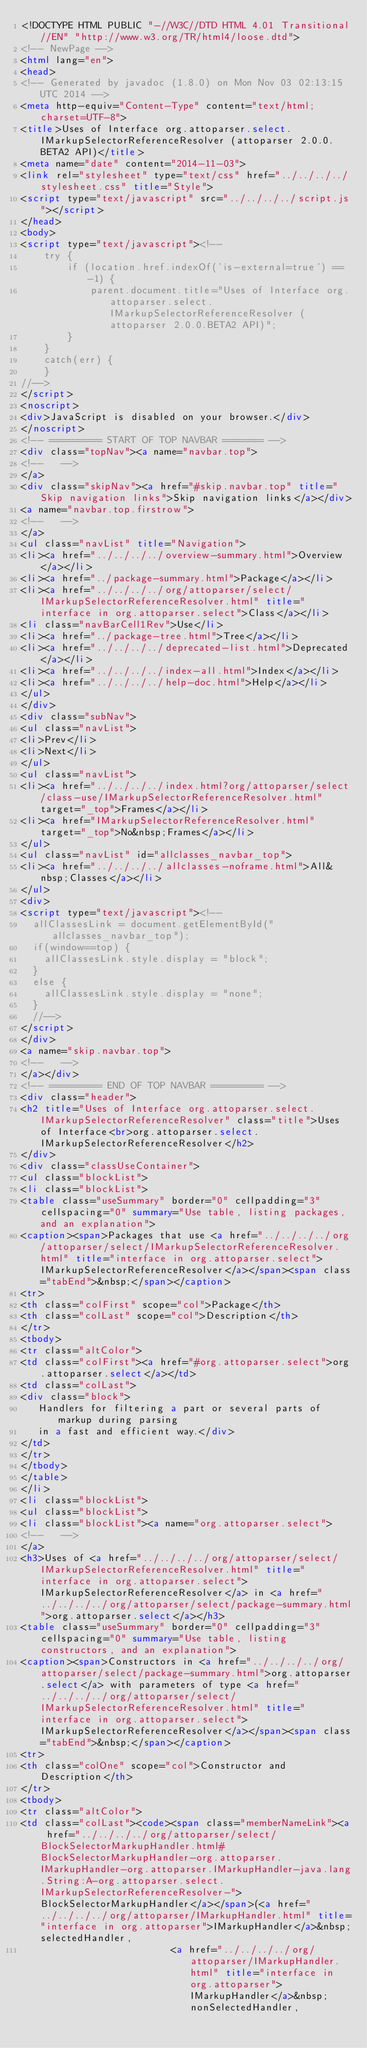<code> <loc_0><loc_0><loc_500><loc_500><_HTML_><!DOCTYPE HTML PUBLIC "-//W3C//DTD HTML 4.01 Transitional//EN" "http://www.w3.org/TR/html4/loose.dtd">
<!-- NewPage -->
<html lang="en">
<head>
<!-- Generated by javadoc (1.8.0) on Mon Nov 03 02:13:15 UTC 2014 -->
<meta http-equiv="Content-Type" content="text/html; charset=UTF-8">
<title>Uses of Interface org.attoparser.select.IMarkupSelectorReferenceResolver (attoparser 2.0.0.BETA2 API)</title>
<meta name="date" content="2014-11-03">
<link rel="stylesheet" type="text/css" href="../../../../stylesheet.css" title="Style">
<script type="text/javascript" src="../../../../script.js"></script>
</head>
<body>
<script type="text/javascript"><!--
    try {
        if (location.href.indexOf('is-external=true') == -1) {
            parent.document.title="Uses of Interface org.attoparser.select.IMarkupSelectorReferenceResolver (attoparser 2.0.0.BETA2 API)";
        }
    }
    catch(err) {
    }
//-->
</script>
<noscript>
<div>JavaScript is disabled on your browser.</div>
</noscript>
<!-- ========= START OF TOP NAVBAR ======= -->
<div class="topNav"><a name="navbar.top">
<!--   -->
</a>
<div class="skipNav"><a href="#skip.navbar.top" title="Skip navigation links">Skip navigation links</a></div>
<a name="navbar.top.firstrow">
<!--   -->
</a>
<ul class="navList" title="Navigation">
<li><a href="../../../../overview-summary.html">Overview</a></li>
<li><a href="../package-summary.html">Package</a></li>
<li><a href="../../../../org/attoparser/select/IMarkupSelectorReferenceResolver.html" title="interface in org.attoparser.select">Class</a></li>
<li class="navBarCell1Rev">Use</li>
<li><a href="../package-tree.html">Tree</a></li>
<li><a href="../../../../deprecated-list.html">Deprecated</a></li>
<li><a href="../../../../index-all.html">Index</a></li>
<li><a href="../../../../help-doc.html">Help</a></li>
</ul>
</div>
<div class="subNav">
<ul class="navList">
<li>Prev</li>
<li>Next</li>
</ul>
<ul class="navList">
<li><a href="../../../../index.html?org/attoparser/select/class-use/IMarkupSelectorReferenceResolver.html" target="_top">Frames</a></li>
<li><a href="IMarkupSelectorReferenceResolver.html" target="_top">No&nbsp;Frames</a></li>
</ul>
<ul class="navList" id="allclasses_navbar_top">
<li><a href="../../../../allclasses-noframe.html">All&nbsp;Classes</a></li>
</ul>
<div>
<script type="text/javascript"><!--
  allClassesLink = document.getElementById("allclasses_navbar_top");
  if(window==top) {
    allClassesLink.style.display = "block";
  }
  else {
    allClassesLink.style.display = "none";
  }
  //-->
</script>
</div>
<a name="skip.navbar.top">
<!--   -->
</a></div>
<!-- ========= END OF TOP NAVBAR ========= -->
<div class="header">
<h2 title="Uses of Interface org.attoparser.select.IMarkupSelectorReferenceResolver" class="title">Uses of Interface<br>org.attoparser.select.IMarkupSelectorReferenceResolver</h2>
</div>
<div class="classUseContainer">
<ul class="blockList">
<li class="blockList">
<table class="useSummary" border="0" cellpadding="3" cellspacing="0" summary="Use table, listing packages, and an explanation">
<caption><span>Packages that use <a href="../../../../org/attoparser/select/IMarkupSelectorReferenceResolver.html" title="interface in org.attoparser.select">IMarkupSelectorReferenceResolver</a></span><span class="tabEnd">&nbsp;</span></caption>
<tr>
<th class="colFirst" scope="col">Package</th>
<th class="colLast" scope="col">Description</th>
</tr>
<tbody>
<tr class="altColor">
<td class="colFirst"><a href="#org.attoparser.select">org.attoparser.select</a></td>
<td class="colLast">
<div class="block">
   Handlers for filtering a part or several parts of markup during parsing
   in a fast and efficient way.</div>
</td>
</tr>
</tbody>
</table>
</li>
<li class="blockList">
<ul class="blockList">
<li class="blockList"><a name="org.attoparser.select">
<!--   -->
</a>
<h3>Uses of <a href="../../../../org/attoparser/select/IMarkupSelectorReferenceResolver.html" title="interface in org.attoparser.select">IMarkupSelectorReferenceResolver</a> in <a href="../../../../org/attoparser/select/package-summary.html">org.attoparser.select</a></h3>
<table class="useSummary" border="0" cellpadding="3" cellspacing="0" summary="Use table, listing constructors, and an explanation">
<caption><span>Constructors in <a href="../../../../org/attoparser/select/package-summary.html">org.attoparser.select</a> with parameters of type <a href="../../../../org/attoparser/select/IMarkupSelectorReferenceResolver.html" title="interface in org.attoparser.select">IMarkupSelectorReferenceResolver</a></span><span class="tabEnd">&nbsp;</span></caption>
<tr>
<th class="colOne" scope="col">Constructor and Description</th>
</tr>
<tbody>
<tr class="altColor">
<td class="colLast"><code><span class="memberNameLink"><a href="../../../../org/attoparser/select/BlockSelectorMarkupHandler.html#BlockSelectorMarkupHandler-org.attoparser.IMarkupHandler-org.attoparser.IMarkupHandler-java.lang.String:A-org.attoparser.select.IMarkupSelectorReferenceResolver-">BlockSelectorMarkupHandler</a></span>(<a href="../../../../org/attoparser/IMarkupHandler.html" title="interface in org.attoparser">IMarkupHandler</a>&nbsp;selectedHandler,
                          <a href="../../../../org/attoparser/IMarkupHandler.html" title="interface in org.attoparser">IMarkupHandler</a>&nbsp;nonSelectedHandler,</code> 